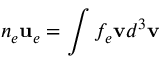Convert formula to latex. <formula><loc_0><loc_0><loc_500><loc_500>n _ { e } u _ { e } = \int f _ { e } v d ^ { 3 } v</formula> 